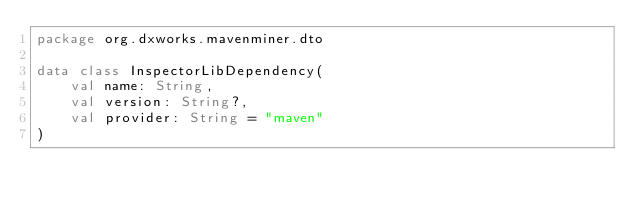Convert code to text. <code><loc_0><loc_0><loc_500><loc_500><_Kotlin_>package org.dxworks.mavenminer.dto

data class InspectorLibDependency(
    val name: String,
    val version: String?,
    val provider: String = "maven"
)
</code> 